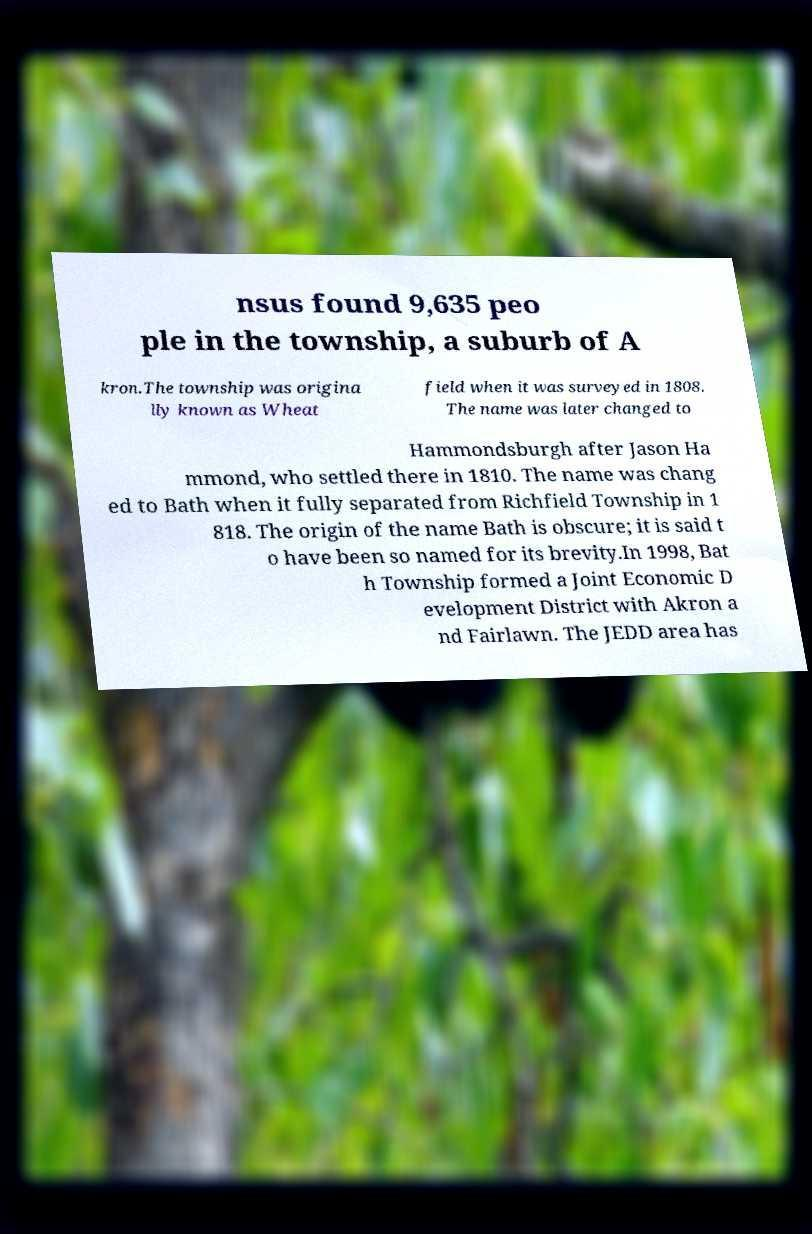Could you extract and type out the text from this image? nsus found 9,635 peo ple in the township, a suburb of A kron.The township was origina lly known as Wheat field when it was surveyed in 1808. The name was later changed to Hammondsburgh after Jason Ha mmond, who settled there in 1810. The name was chang ed to Bath when it fully separated from Richfield Township in 1 818. The origin of the name Bath is obscure; it is said t o have been so named for its brevity.In 1998, Bat h Township formed a Joint Economic D evelopment District with Akron a nd Fairlawn. The JEDD area has 